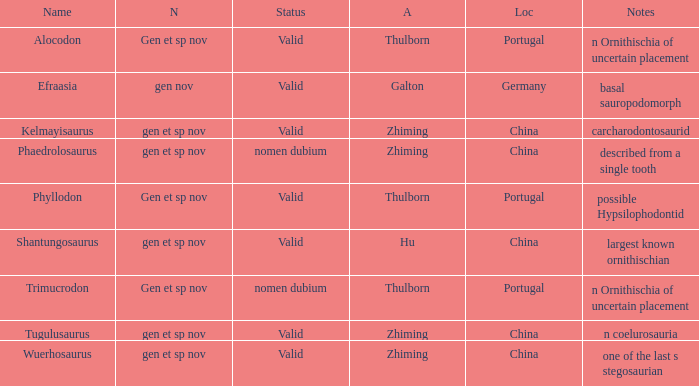What is the Name of the dinosaur that was discovered in the Location, China, and whose Notes are, "described from a single tooth"? Phaedrolosaurus. 